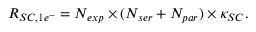Convert formula to latex. <formula><loc_0><loc_0><loc_500><loc_500>R _ { S C , 1 e ^ { - } } = N _ { e x p } \times ( N _ { s e r } + N _ { p a r } ) \times \kappa _ { S C } .</formula> 